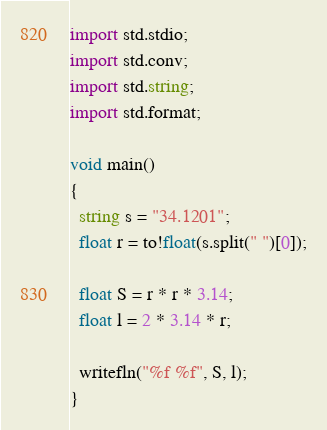<code> <loc_0><loc_0><loc_500><loc_500><_D_>import std.stdio;
import std.conv;
import std.string;
import std.format;

void main()
{
  string s = "34.1201";
  float r = to!float(s.split(" ")[0]);

  float S = r * r * 3.14;
  float l = 2 * 3.14 * r;

  writefln("%f %f", S, l);
}</code> 